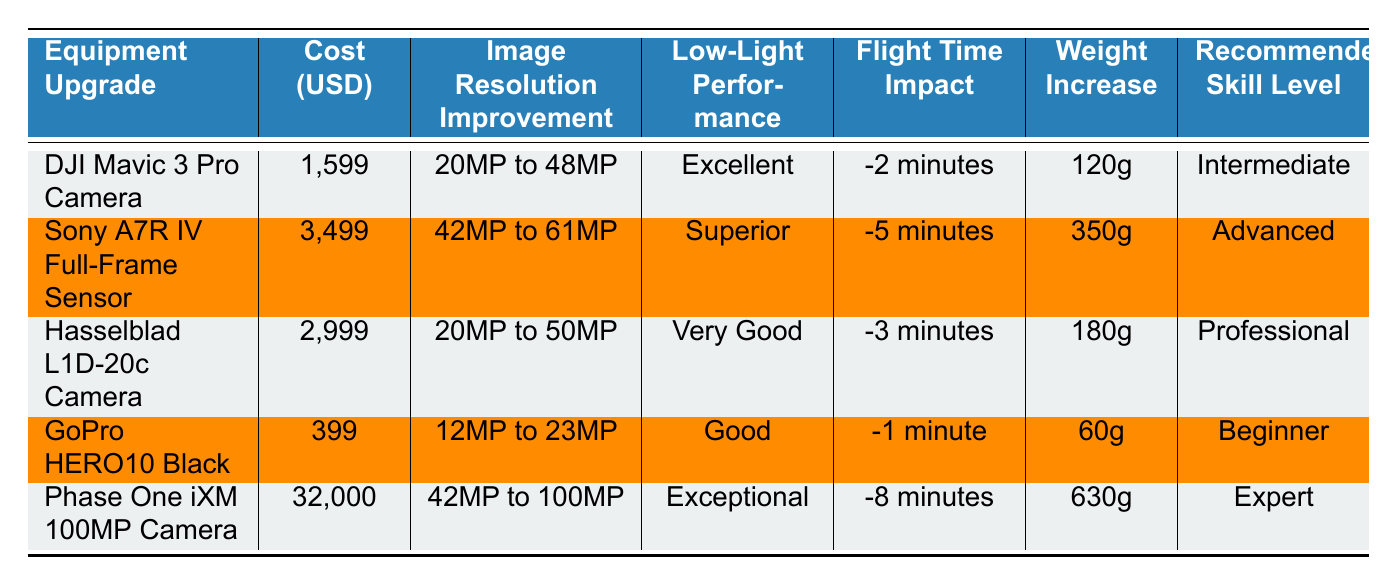What is the cost of the DJI Mavic 3 Pro Camera? The table lists the cost of the DJI Mavic 3 Pro Camera in the corresponding column. The specified cost is 1,599 USD.
Answer: 1,599 USD Which upgrade has the best low-light performance? The low-light performance is rated in the table for each upgrade. By comparing the values, the Phase One iXM 100MP Camera has the rating "Exceptional," which is the highest.
Answer: Phase One iXM 100MP Camera What is the weight increase of the Sony A7R IV Full-Frame Sensor? The table indicates the weight increase for the Sony A7R IV Full-Frame Sensor in the weight increase column, which shows it is 350g.
Answer: 350g If I combine the flight time impacts of the DJI Mavic 3 Pro Camera and the GoPro HERO10 Black, what would that be? The flight time impacts for both cameras are -2 minutes for the DJI Mavic 3 Pro Camera and -1 minute for the GoPro HERO10 Black. Adding these together (-2 + -1) gives a combined flight time impact of -3 minutes.
Answer: -3 minutes Is the Hasselblad L1D-20c Camera more expensive than the DJI Mavic 3 Pro Camera? By comparing the costs in the cost column, the Hasselblad L1D-20c Camera costs 2,999 USD, while the DJI Mavic 3 Pro Camera costs 1,599 USD. Thus, the Hasselblad is more expensive.
Answer: Yes What is the average image resolution improvement for all the cameras listed? The image resolution improvements are as follows: DJI Mavic 3 Pro (48MP), Sony A7R IV (61MP), Hasselblad L1D-20c (50MP), GoPro HERO10 (23MP), and Phase One iXM (100MP). To find the average, we add the values (48 + 61 + 50 + 23 + 100) which totals to 282, and then divide by 5 (282/5 = 56.4).
Answer: 56.4MP Are all upgrades suitable for beginners? Checking the recommended skill level column, the GoPro HERO10 Black is the only upgrade listed as suitable for beginners, while others range from Intermediate to Expert. Therefore, not all upgrades are suitable for beginners.
Answer: No What is the total cost of the three most expensive upgrades? The three most expensive upgrades are the Phase One iXM 100MP Camera (32,000 USD), the Sony A7R IV Full-Frame Sensor (3,499 USD), and the Hasselblad L1D-20c Camera (2,999 USD). Adding these costs together (32,000 + 3,499 + 2,999) amounts to 38,498 USD.
Answer: 38,498 USD Which equipment upgrade provides the smallest flight time impact? The flight time impacts are listed for each upgrade, with the GoPro HERO10 Black showing the smallest impact at -1 minute, while others have larger negative impacts.
Answer: GoPro HERO10 Black 